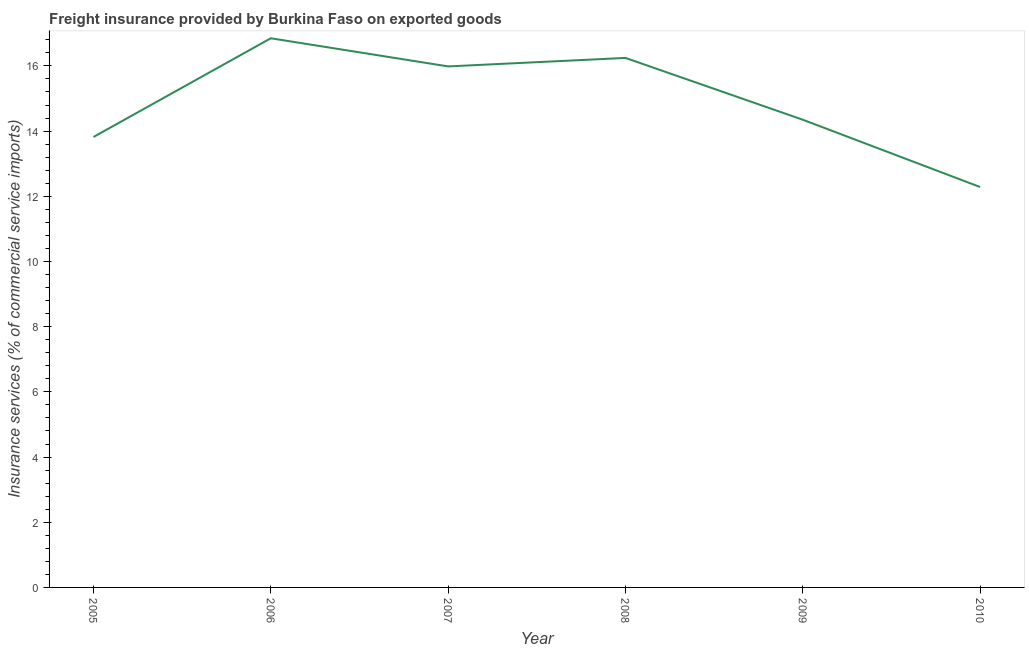What is the freight insurance in 2007?
Make the answer very short. 15.98. Across all years, what is the maximum freight insurance?
Provide a short and direct response. 16.85. Across all years, what is the minimum freight insurance?
Give a very brief answer. 12.28. In which year was the freight insurance maximum?
Your answer should be compact. 2006. What is the sum of the freight insurance?
Your response must be concise. 89.53. What is the difference between the freight insurance in 2007 and 2010?
Offer a very short reply. 3.7. What is the average freight insurance per year?
Provide a short and direct response. 14.92. What is the median freight insurance?
Offer a very short reply. 15.17. In how many years, is the freight insurance greater than 10.8 %?
Your answer should be compact. 6. What is the ratio of the freight insurance in 2005 to that in 2007?
Provide a succinct answer. 0.86. Is the difference between the freight insurance in 2008 and 2010 greater than the difference between any two years?
Provide a succinct answer. No. What is the difference between the highest and the second highest freight insurance?
Give a very brief answer. 0.6. What is the difference between the highest and the lowest freight insurance?
Offer a very short reply. 4.56. Does the freight insurance monotonically increase over the years?
Provide a succinct answer. No. How many lines are there?
Give a very brief answer. 1. What is the difference between two consecutive major ticks on the Y-axis?
Your response must be concise. 2. What is the title of the graph?
Your answer should be very brief. Freight insurance provided by Burkina Faso on exported goods . What is the label or title of the X-axis?
Provide a short and direct response. Year. What is the label or title of the Y-axis?
Ensure brevity in your answer.  Insurance services (% of commercial service imports). What is the Insurance services (% of commercial service imports) of 2005?
Ensure brevity in your answer.  13.82. What is the Insurance services (% of commercial service imports) in 2006?
Your answer should be compact. 16.85. What is the Insurance services (% of commercial service imports) in 2007?
Give a very brief answer. 15.98. What is the Insurance services (% of commercial service imports) of 2008?
Your answer should be compact. 16.24. What is the Insurance services (% of commercial service imports) of 2009?
Provide a short and direct response. 14.35. What is the Insurance services (% of commercial service imports) of 2010?
Ensure brevity in your answer.  12.28. What is the difference between the Insurance services (% of commercial service imports) in 2005 and 2006?
Offer a very short reply. -3.03. What is the difference between the Insurance services (% of commercial service imports) in 2005 and 2007?
Provide a short and direct response. -2.17. What is the difference between the Insurance services (% of commercial service imports) in 2005 and 2008?
Ensure brevity in your answer.  -2.43. What is the difference between the Insurance services (% of commercial service imports) in 2005 and 2009?
Offer a terse response. -0.53. What is the difference between the Insurance services (% of commercial service imports) in 2005 and 2010?
Your answer should be compact. 1.54. What is the difference between the Insurance services (% of commercial service imports) in 2006 and 2007?
Make the answer very short. 0.86. What is the difference between the Insurance services (% of commercial service imports) in 2006 and 2008?
Offer a very short reply. 0.6. What is the difference between the Insurance services (% of commercial service imports) in 2006 and 2009?
Keep it short and to the point. 2.5. What is the difference between the Insurance services (% of commercial service imports) in 2006 and 2010?
Offer a terse response. 4.56. What is the difference between the Insurance services (% of commercial service imports) in 2007 and 2008?
Your answer should be compact. -0.26. What is the difference between the Insurance services (% of commercial service imports) in 2007 and 2009?
Provide a succinct answer. 1.64. What is the difference between the Insurance services (% of commercial service imports) in 2007 and 2010?
Give a very brief answer. 3.7. What is the difference between the Insurance services (% of commercial service imports) in 2008 and 2009?
Ensure brevity in your answer.  1.9. What is the difference between the Insurance services (% of commercial service imports) in 2008 and 2010?
Keep it short and to the point. 3.96. What is the difference between the Insurance services (% of commercial service imports) in 2009 and 2010?
Your answer should be very brief. 2.06. What is the ratio of the Insurance services (% of commercial service imports) in 2005 to that in 2006?
Your response must be concise. 0.82. What is the ratio of the Insurance services (% of commercial service imports) in 2005 to that in 2007?
Your response must be concise. 0.86. What is the ratio of the Insurance services (% of commercial service imports) in 2005 to that in 2008?
Offer a terse response. 0.85. What is the ratio of the Insurance services (% of commercial service imports) in 2005 to that in 2009?
Give a very brief answer. 0.96. What is the ratio of the Insurance services (% of commercial service imports) in 2006 to that in 2007?
Give a very brief answer. 1.05. What is the ratio of the Insurance services (% of commercial service imports) in 2006 to that in 2008?
Offer a terse response. 1.04. What is the ratio of the Insurance services (% of commercial service imports) in 2006 to that in 2009?
Ensure brevity in your answer.  1.17. What is the ratio of the Insurance services (% of commercial service imports) in 2006 to that in 2010?
Offer a very short reply. 1.37. What is the ratio of the Insurance services (% of commercial service imports) in 2007 to that in 2008?
Offer a terse response. 0.98. What is the ratio of the Insurance services (% of commercial service imports) in 2007 to that in 2009?
Make the answer very short. 1.11. What is the ratio of the Insurance services (% of commercial service imports) in 2007 to that in 2010?
Your response must be concise. 1.3. What is the ratio of the Insurance services (% of commercial service imports) in 2008 to that in 2009?
Your answer should be very brief. 1.13. What is the ratio of the Insurance services (% of commercial service imports) in 2008 to that in 2010?
Provide a succinct answer. 1.32. What is the ratio of the Insurance services (% of commercial service imports) in 2009 to that in 2010?
Your answer should be very brief. 1.17. 